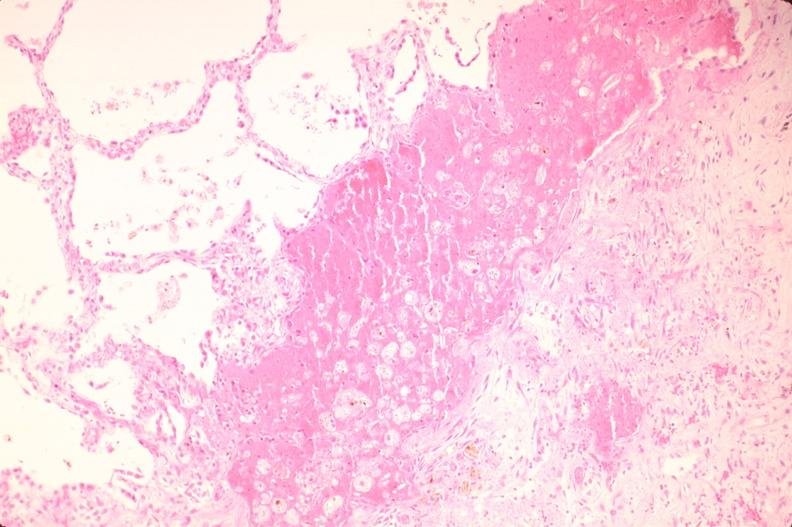s respiratory present?
Answer the question using a single word or phrase. Yes 